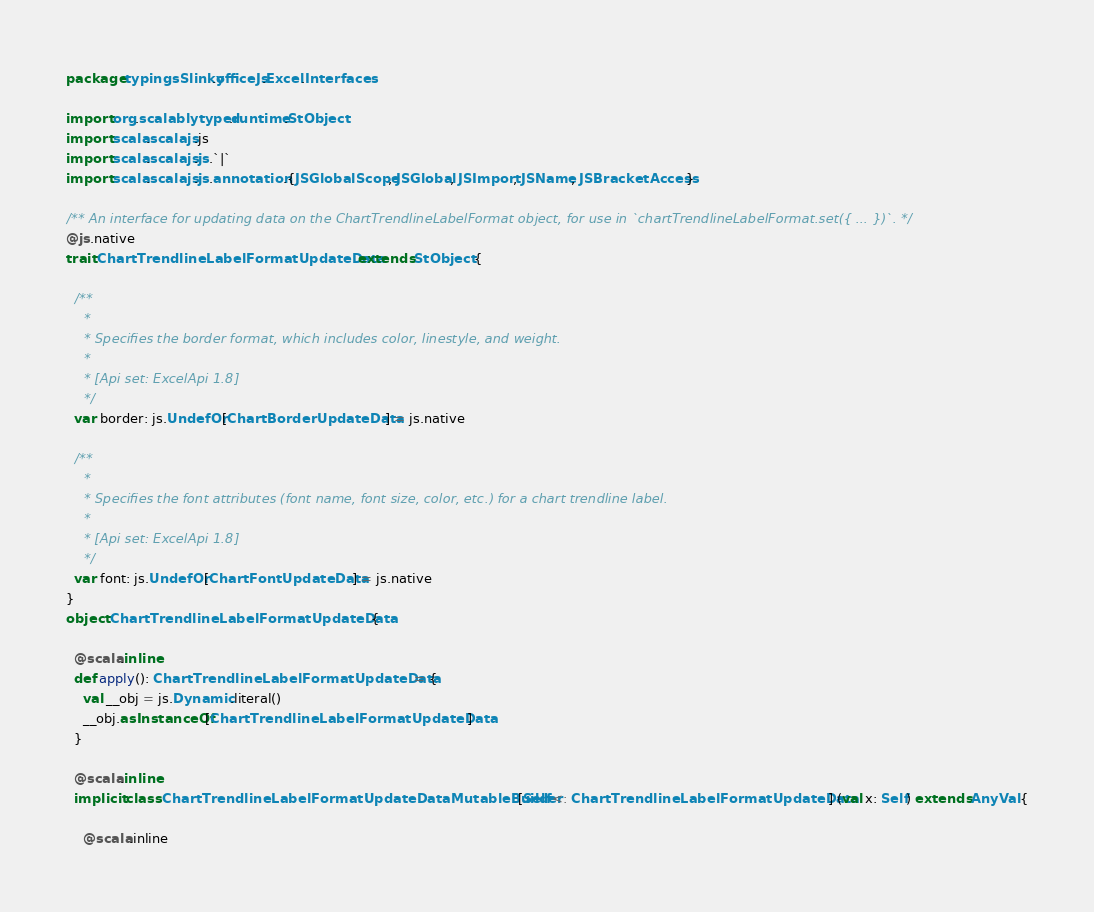Convert code to text. <code><loc_0><loc_0><loc_500><loc_500><_Scala_>package typingsSlinky.officeJs.Excel.Interfaces

import org.scalablytyped.runtime.StObject
import scala.scalajs.js
import scala.scalajs.js.`|`
import scala.scalajs.js.annotation.{JSGlobalScope, JSGlobal, JSImport, JSName, JSBracketAccess}

/** An interface for updating data on the ChartTrendlineLabelFormat object, for use in `chartTrendlineLabelFormat.set({ ... })`. */
@js.native
trait ChartTrendlineLabelFormatUpdateData extends StObject {
  
  /**
    *
    * Specifies the border format, which includes color, linestyle, and weight.
    *
    * [Api set: ExcelApi 1.8]
    */
  var border: js.UndefOr[ChartBorderUpdateData] = js.native
  
  /**
    *
    * Specifies the font attributes (font name, font size, color, etc.) for a chart trendline label.
    *
    * [Api set: ExcelApi 1.8]
    */
  var font: js.UndefOr[ChartFontUpdateData] = js.native
}
object ChartTrendlineLabelFormatUpdateData {
  
  @scala.inline
  def apply(): ChartTrendlineLabelFormatUpdateData = {
    val __obj = js.Dynamic.literal()
    __obj.asInstanceOf[ChartTrendlineLabelFormatUpdateData]
  }
  
  @scala.inline
  implicit class ChartTrendlineLabelFormatUpdateDataMutableBuilder[Self <: ChartTrendlineLabelFormatUpdateData] (val x: Self) extends AnyVal {
    
    @scala.inline</code> 